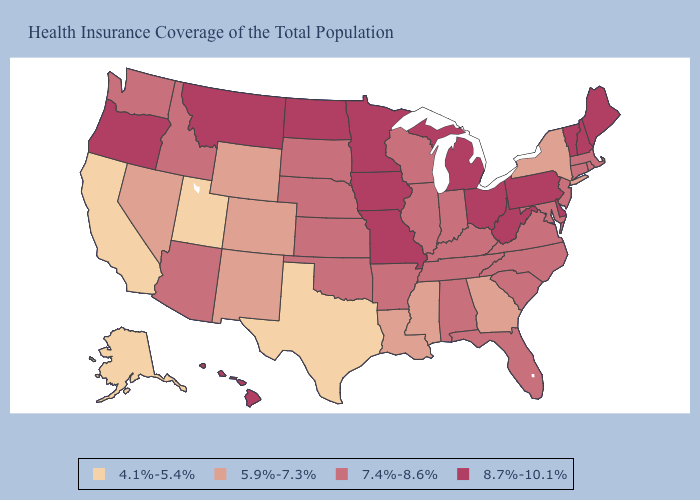Does the first symbol in the legend represent the smallest category?
Answer briefly. Yes. Among the states that border Michigan , does Ohio have the highest value?
Write a very short answer. Yes. What is the value of Idaho?
Answer briefly. 7.4%-8.6%. Does Idaho have the same value as New York?
Concise answer only. No. What is the lowest value in states that border Kentucky?
Keep it brief. 7.4%-8.6%. Which states hav the highest value in the Northeast?
Quick response, please. Maine, New Hampshire, Pennsylvania, Vermont. Among the states that border Nebraska , which have the highest value?
Concise answer only. Iowa, Missouri. Name the states that have a value in the range 8.7%-10.1%?
Write a very short answer. Delaware, Hawaii, Iowa, Maine, Michigan, Minnesota, Missouri, Montana, New Hampshire, North Dakota, Ohio, Oregon, Pennsylvania, Vermont, West Virginia. Does the first symbol in the legend represent the smallest category?
Give a very brief answer. Yes. Name the states that have a value in the range 4.1%-5.4%?
Answer briefly. Alaska, California, Texas, Utah. Name the states that have a value in the range 4.1%-5.4%?
Be succinct. Alaska, California, Texas, Utah. Which states have the lowest value in the Northeast?
Keep it brief. New York. Name the states that have a value in the range 5.9%-7.3%?
Concise answer only. Colorado, Georgia, Louisiana, Mississippi, Nevada, New Mexico, New York, Wyoming. Does Nebraska have a higher value than New Mexico?
Short answer required. Yes. Is the legend a continuous bar?
Give a very brief answer. No. 